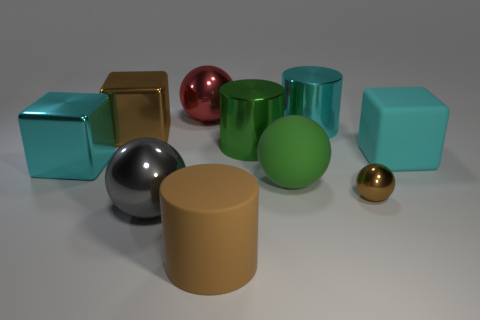There is a rubber thing that is the same color as the tiny ball; what shape is it?
Your response must be concise. Cylinder. There is a thing that is the same color as the large rubber ball; what size is it?
Make the answer very short. Large. What number of other objects are the same shape as the large gray object?
Offer a terse response. 3. What is the shape of the brown object that is both behind the large matte cylinder and on the right side of the large red thing?
Provide a short and direct response. Sphere. There is a big brown shiny thing; are there any shiny balls on the right side of it?
Offer a very short reply. Yes. The green thing that is the same shape as the large gray object is what size?
Make the answer very short. Large. Is there anything else that has the same size as the gray object?
Provide a succinct answer. Yes. Is the shape of the big red shiny thing the same as the tiny brown metallic thing?
Give a very brief answer. Yes. What size is the metal cube that is to the right of the large metallic block in front of the brown cube?
Your answer should be compact. Large. What is the color of the rubber object that is the same shape as the gray metal object?
Offer a terse response. Green. 